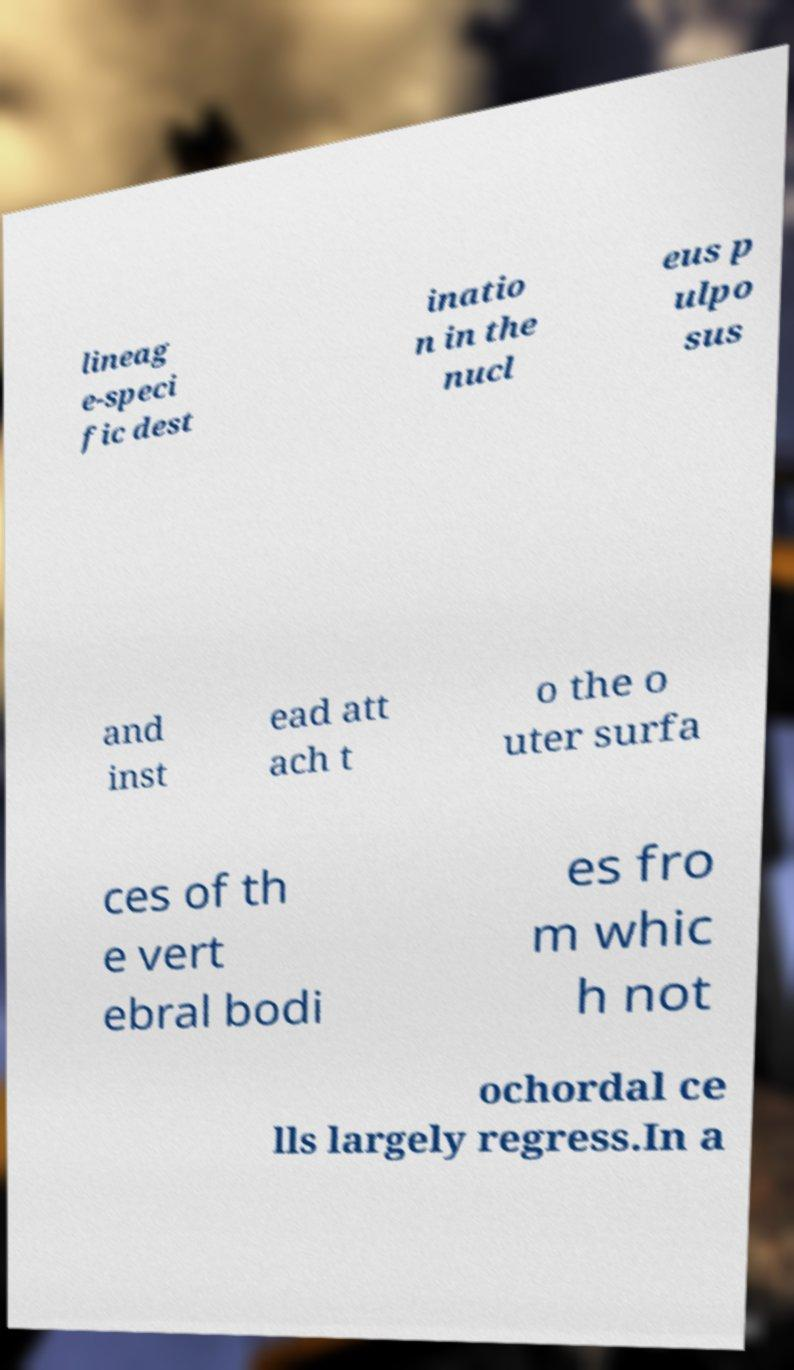Please read and relay the text visible in this image. What does it say? lineag e-speci fic dest inatio n in the nucl eus p ulpo sus and inst ead att ach t o the o uter surfa ces of th e vert ebral bodi es fro m whic h not ochordal ce lls largely regress.In a 